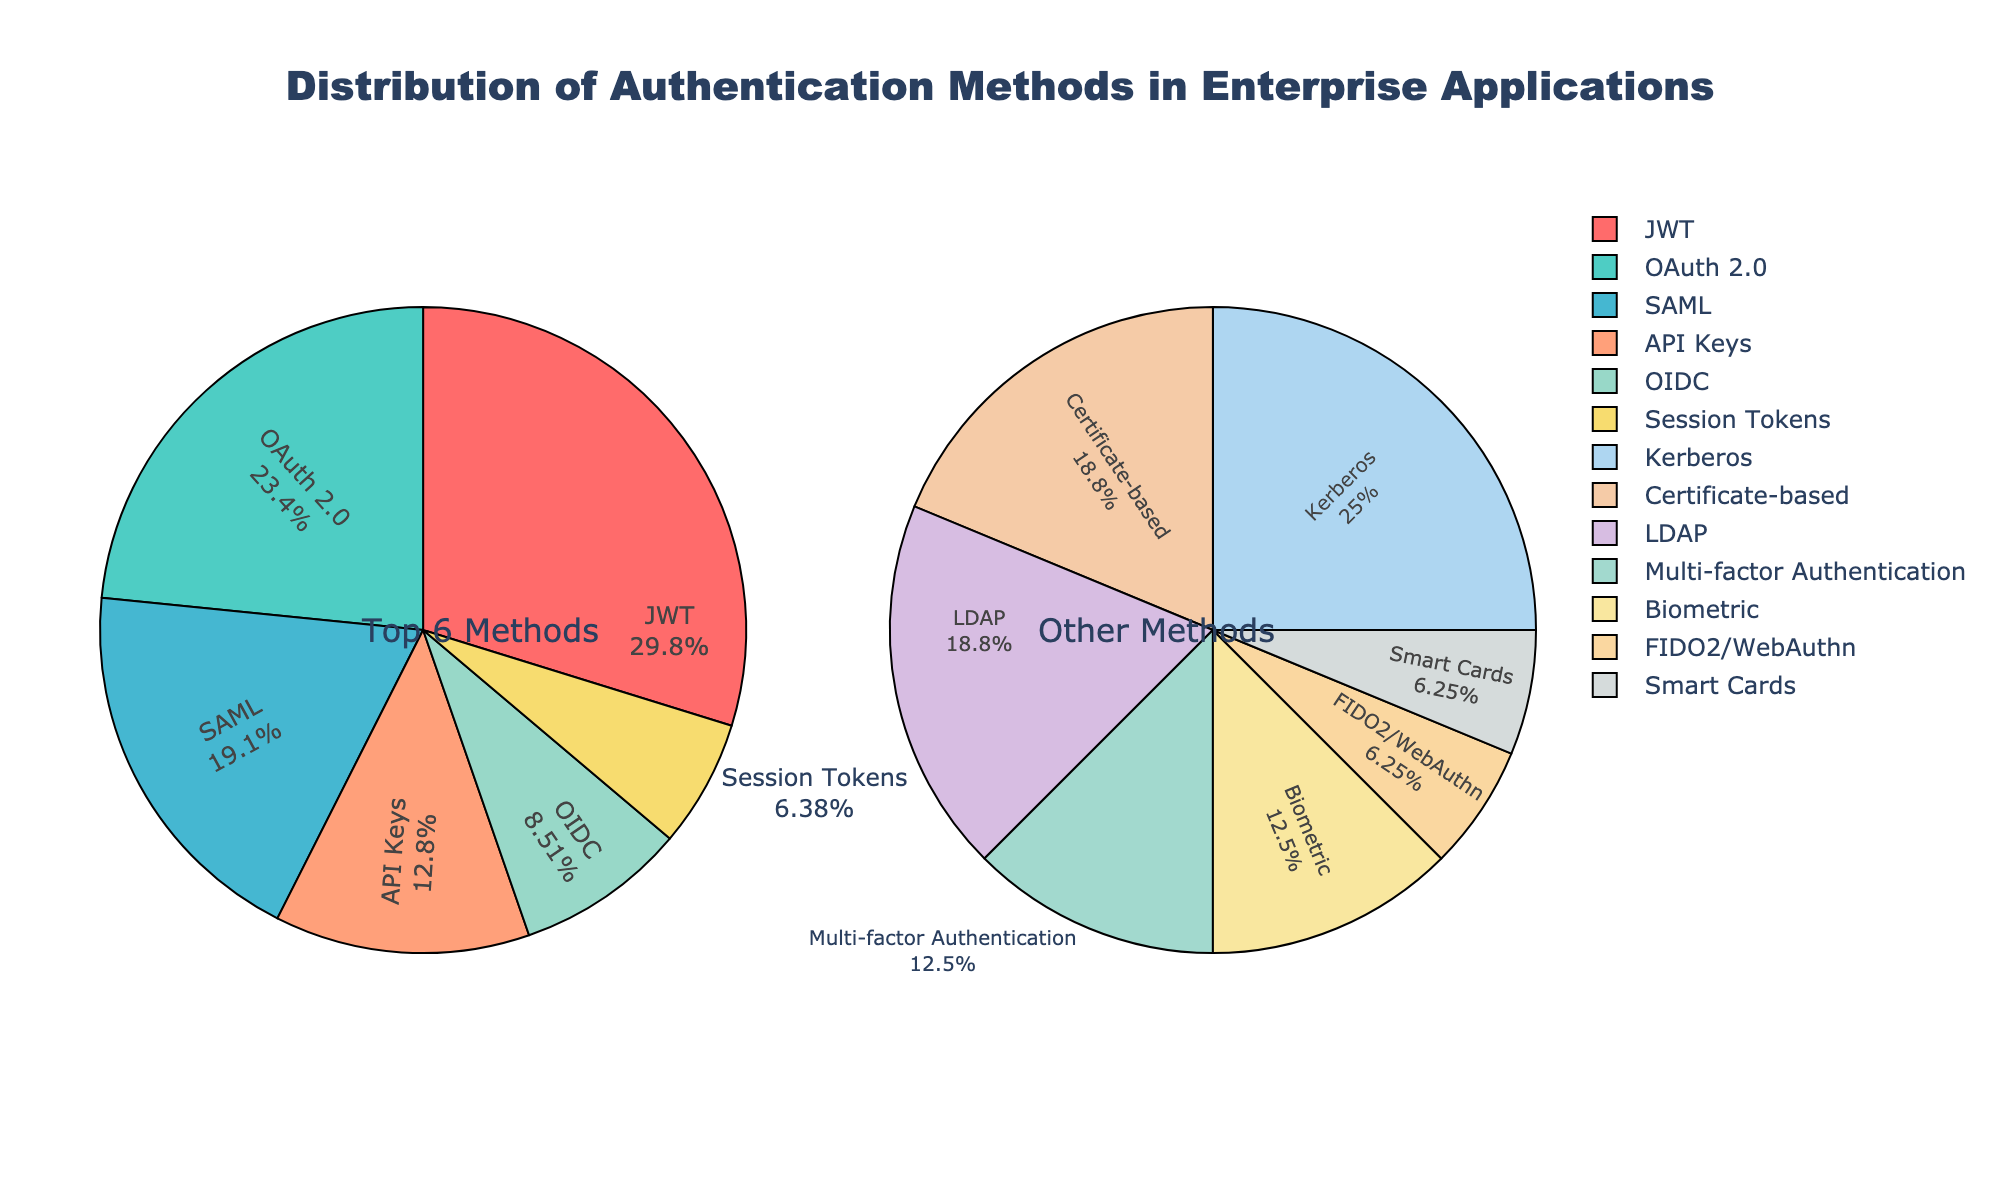What's the most common authentication method used in enterprise applications? Look at the labels and percentages in the "Top 6 Methods" pie chart. The largest slice of the pie chart represents the most common method. JWT has the largest slice with 28%.
Answer: JWT Which authentication method has the largest percentage in the "Others" category? Examine the "Others" pie chart for the slice with the largest percentage. Kerberos has the largest percentage in the "Others" category with 4%.
Answer: Kerberos What's the combined percentage of JWT and OAuth 2.0 authentication methods? Add the percentages of JWT (28%) and OAuth 2.0 (22%). 28% + 22% = 50%.
Answer: 50% How many authentication methods have a percentage less than or equal to 3%? In the "Others" pie chart, count the slices with percentages equal to or less than 3%: Certificate-based, LDAP, Multi-factor Authentication, Biometric, FIDO2/WebAuthn, and Smart Cards. There are 6 methods.
Answer: 6 What's the difference in percentage between SAML and API Keys? Subtract the percentage of API Keys (12%) from the percentage of SAML (18%). 18% - 12% = 6%.
Answer: 6% Which authentication method in the "Top 6 Methods" is represented by a purple slice in the pie chart? Identify the slice with the purple color in the "Top 6 Methods" pie chart. The purple slice represents API Keys with 12%.
Answer: API Keys Which pie chart segment, "Top 6 Methods" or "Others", contains Biometric authentication, and what is its percentage? Biometric authentication is part of the "Others" pie chart, and its percentage is 2%.
Answer: Others, 2% What is the difference in percentage between the least used methods in "Top 6 Methods" and "Others"? Identify the smallest slices in both pie charts: "Top 6 Methods" - Session Tokens (6%), and "Others" - Smart Cards (1%). Calculate the difference: 6% - 1% = 5%.
Answer: 5% 